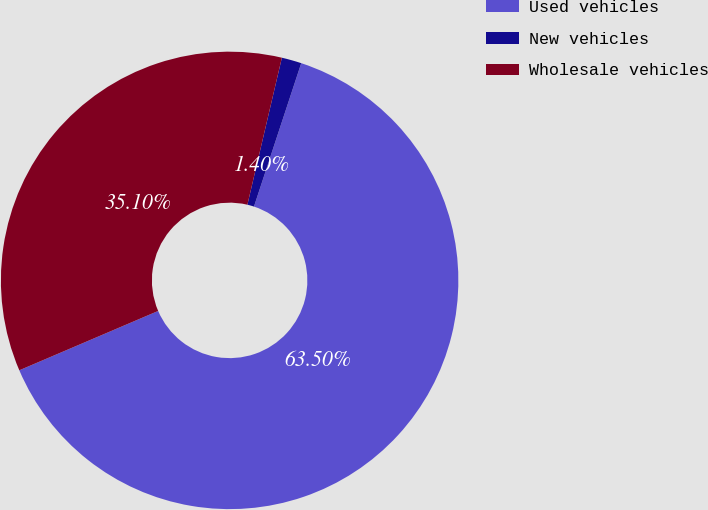<chart> <loc_0><loc_0><loc_500><loc_500><pie_chart><fcel>Used vehicles<fcel>New vehicles<fcel>Wholesale vehicles<nl><fcel>63.51%<fcel>1.4%<fcel>35.1%<nl></chart> 